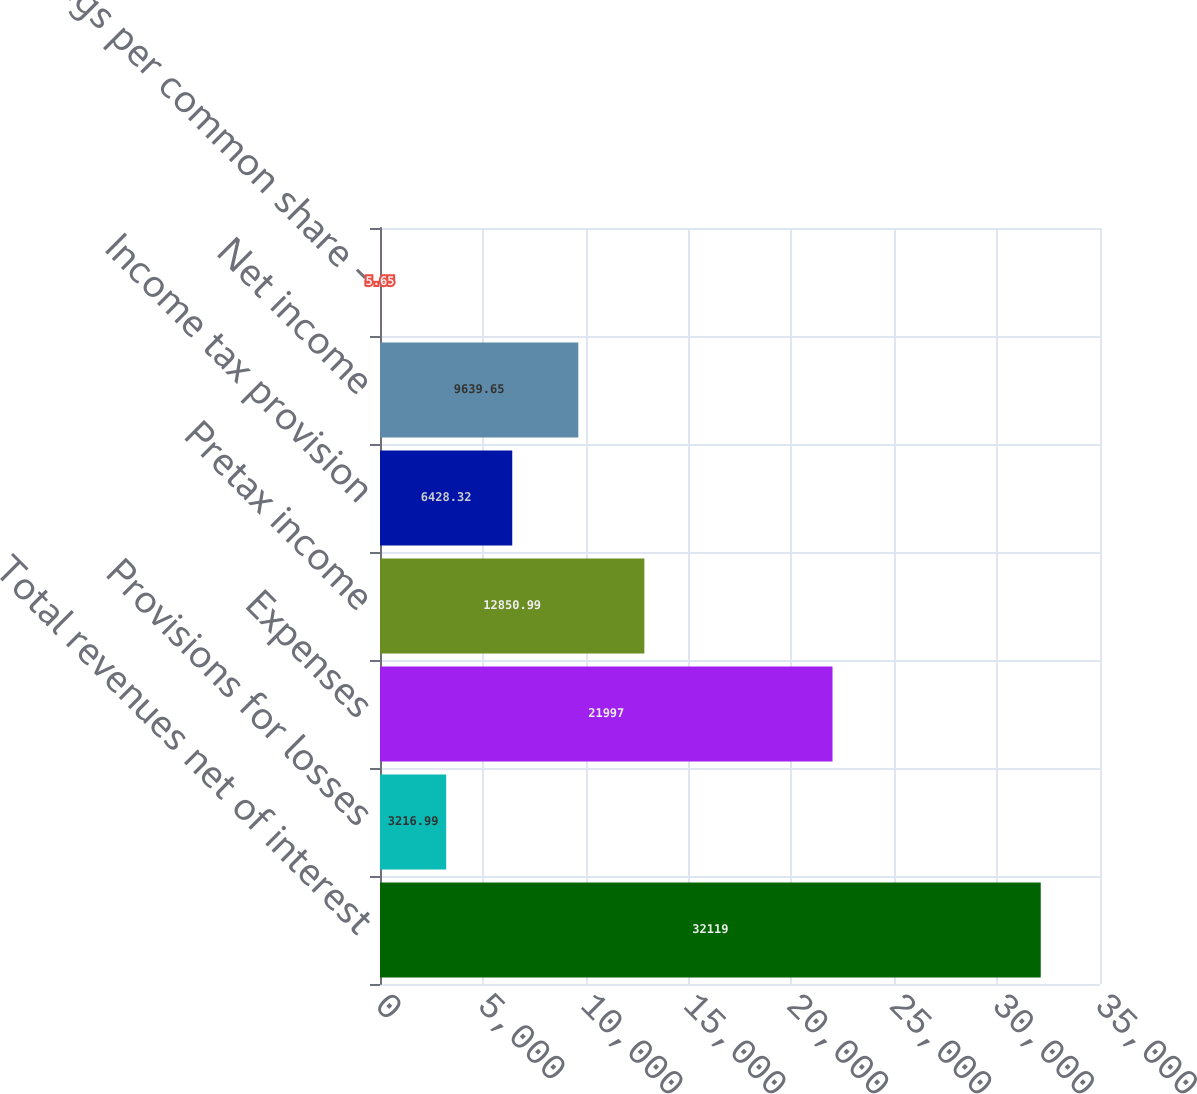<chart> <loc_0><loc_0><loc_500><loc_500><bar_chart><fcel>Total revenues net of interest<fcel>Provisions for losses<fcel>Expenses<fcel>Pretax income<fcel>Income tax provision<fcel>Net income<fcel>Earnings per common share -<nl><fcel>32119<fcel>3216.99<fcel>21997<fcel>12851<fcel>6428.32<fcel>9639.65<fcel>5.65<nl></chart> 